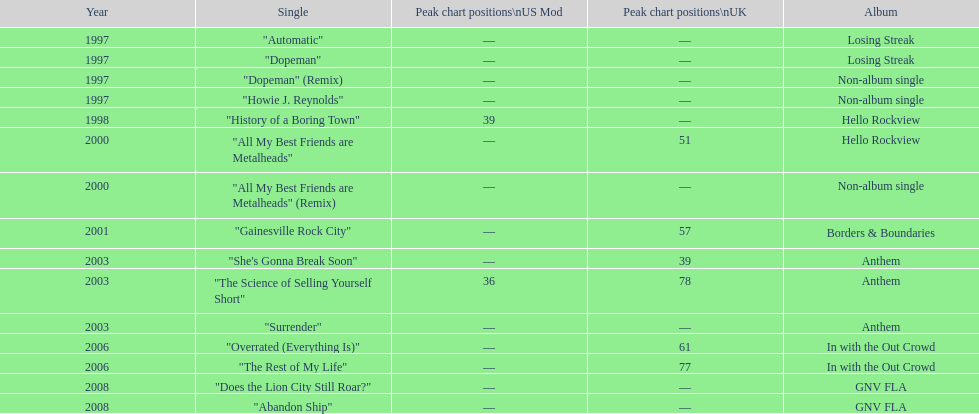Which year has the most singles? 1997. 